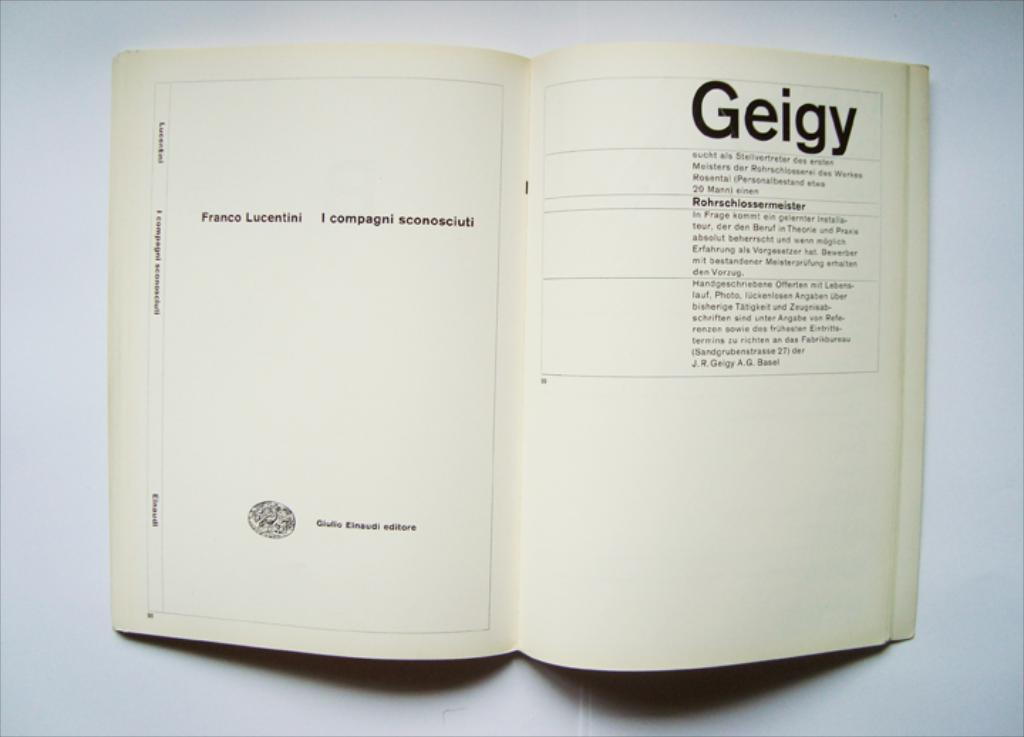<image>
Render a clear and concise summary of the photo. A book written in a foreign language open to a page that says Geigy. 